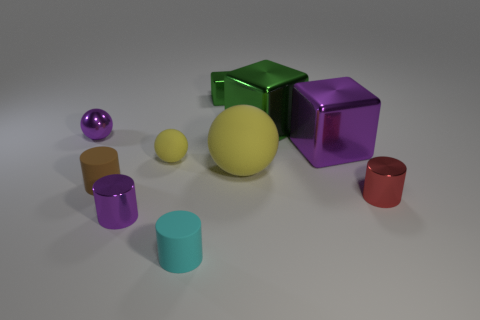Is the tiny matte ball the same color as the big matte sphere?
Offer a terse response. Yes. What is the material of the cyan thing that is the same size as the red object?
Make the answer very short. Rubber. There is a big purple metal thing; how many small purple metal cylinders are in front of it?
Your answer should be very brief. 1. Does the yellow ball that is on the right side of the tiny shiny block have the same material as the cylinder that is on the right side of the tiny cyan rubber cylinder?
Offer a terse response. No. The tiny purple shiny object in front of the purple metallic object that is on the right side of the metallic thing in front of the red cylinder is what shape?
Provide a succinct answer. Cylinder. The small brown matte thing has what shape?
Offer a terse response. Cylinder. What is the shape of the cyan rubber object that is the same size as the purple metal cylinder?
Keep it short and to the point. Cylinder. What number of other objects are there of the same color as the small metallic block?
Provide a succinct answer. 1. There is a green thing that is right of the big matte thing; does it have the same shape as the purple thing to the right of the large yellow matte thing?
Make the answer very short. Yes. What number of objects are matte balls that are on the left side of the small green shiny cube or tiny objects that are in front of the large green metallic thing?
Provide a short and direct response. 6. 